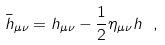<formula> <loc_0><loc_0><loc_500><loc_500>\bar { h } _ { \mu \nu } = h _ { \mu \nu } - \frac { 1 } { 2 } \eta _ { \mu \nu } h \ ,</formula> 